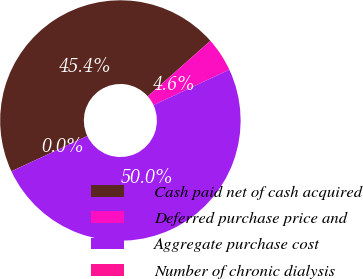<chart> <loc_0><loc_0><loc_500><loc_500><pie_chart><fcel>Cash paid net of cash acquired<fcel>Deferred purchase price and<fcel>Aggregate purchase cost<fcel>Number of chronic dialysis<nl><fcel>45.41%<fcel>4.59%<fcel>49.99%<fcel>0.01%<nl></chart> 